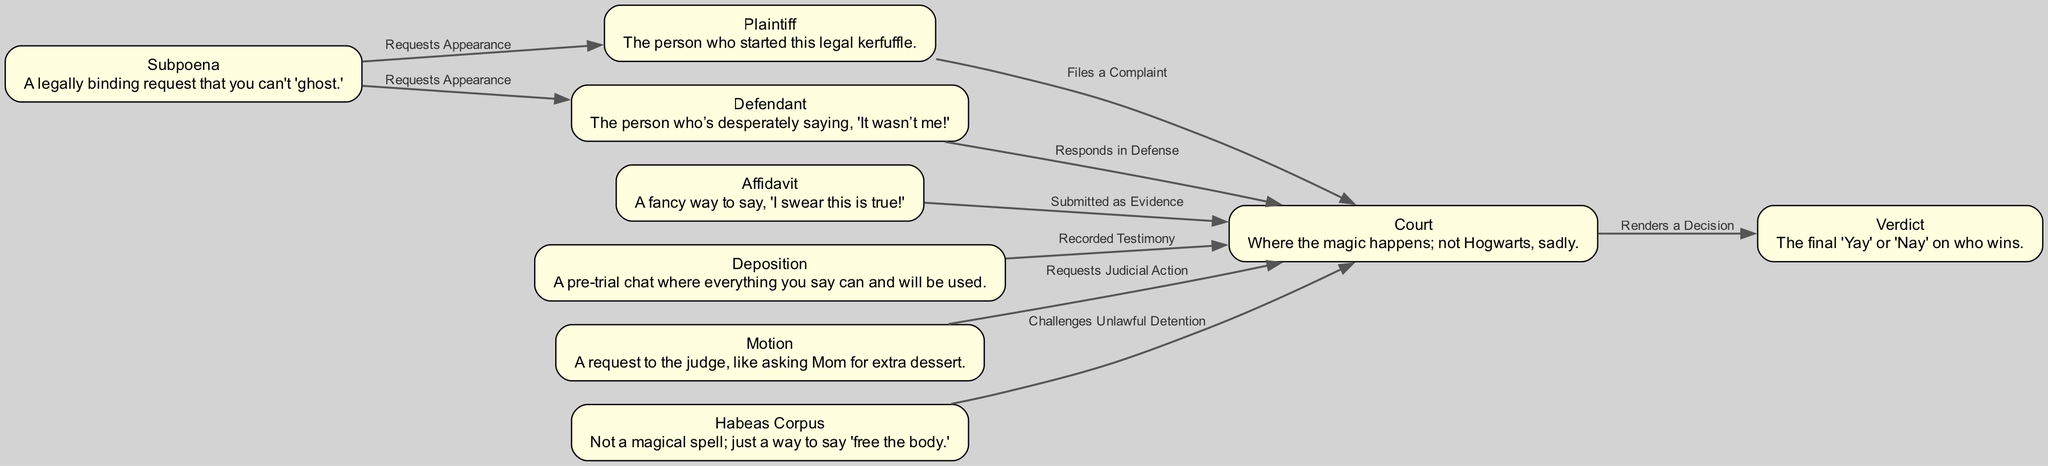How many nodes are in the diagram? By counting each unique entity highlighted in the diagram, we find there are 9 nodes total, including Court, Plaintiff, Defendant, Affidavit, Subpoena, Deposition, Verdict, Motion, and Habeas Corpus.
Answer: 9 What does the Plaintiff do at the Court? The relationship established between the Plaintiff and the Court is indicated by the edge labeled “Files a Complaint,” showing that the Plaintiff initiates the legal process by submitting a complaint at the Court.
Answer: Files a Complaint What is the description of the Affidavit? Looking at the node for Affidavit in the diagram, its description states, “A fancy way to say, 'I swear this is true!'” indicating what an Affidavit represents legally and its significance.
Answer: A fancy way to say, 'I swear this is true!' Who responds to the Court? From the edges leading to the Court, we see that the Defendant is indicated to "Responds in Defense," which identifies their role in the legal process when addressing the Court’s involvement.
Answer: Defendant What action does a Subpoena request from the Plaintiff? The edge connected from Subpoena to Plaintiff is labeled “Requests Appearance,” indicating that a Subpoena legally requires the Plaintiff to appear, showcasing its function within the legal framework.
Answer: Requests Appearance What can be used as evidence in court? The edge from Affidavit to Court labeled “Submitted as Evidence” implies that an Affidavit can serve as evidence in judicial proceedings, demonstrating its importance in supporting legal claims.
Answer: Submitted as Evidence What does a Motion request? The edge labeled “Requests Judicial Action” that connects Motion to Court suggests that a Motion is utilized to request actions from the Judge, akin to a formal proposal in the legal context.
Answer: Requests Judicial Action What is the purpose of Habeas Corpus in this diagram? The edge going from Habeas Corpus to Court, described as “Challenges Unlawful Detention,” defines the purpose of Habeas Corpus within the legal system as a challenge to hold someone in detention without justification.
Answer: Challenges Unlawful Detention What is the final outcome in this legal diagram? The path ending at Verdict indicates the culmination of the legal process as evidenced by the edge “Renders a Decision,” signifying the ultimate 'Yay' or 'Nay' that decides the winner in court proceedings.
Answer: Verdict 